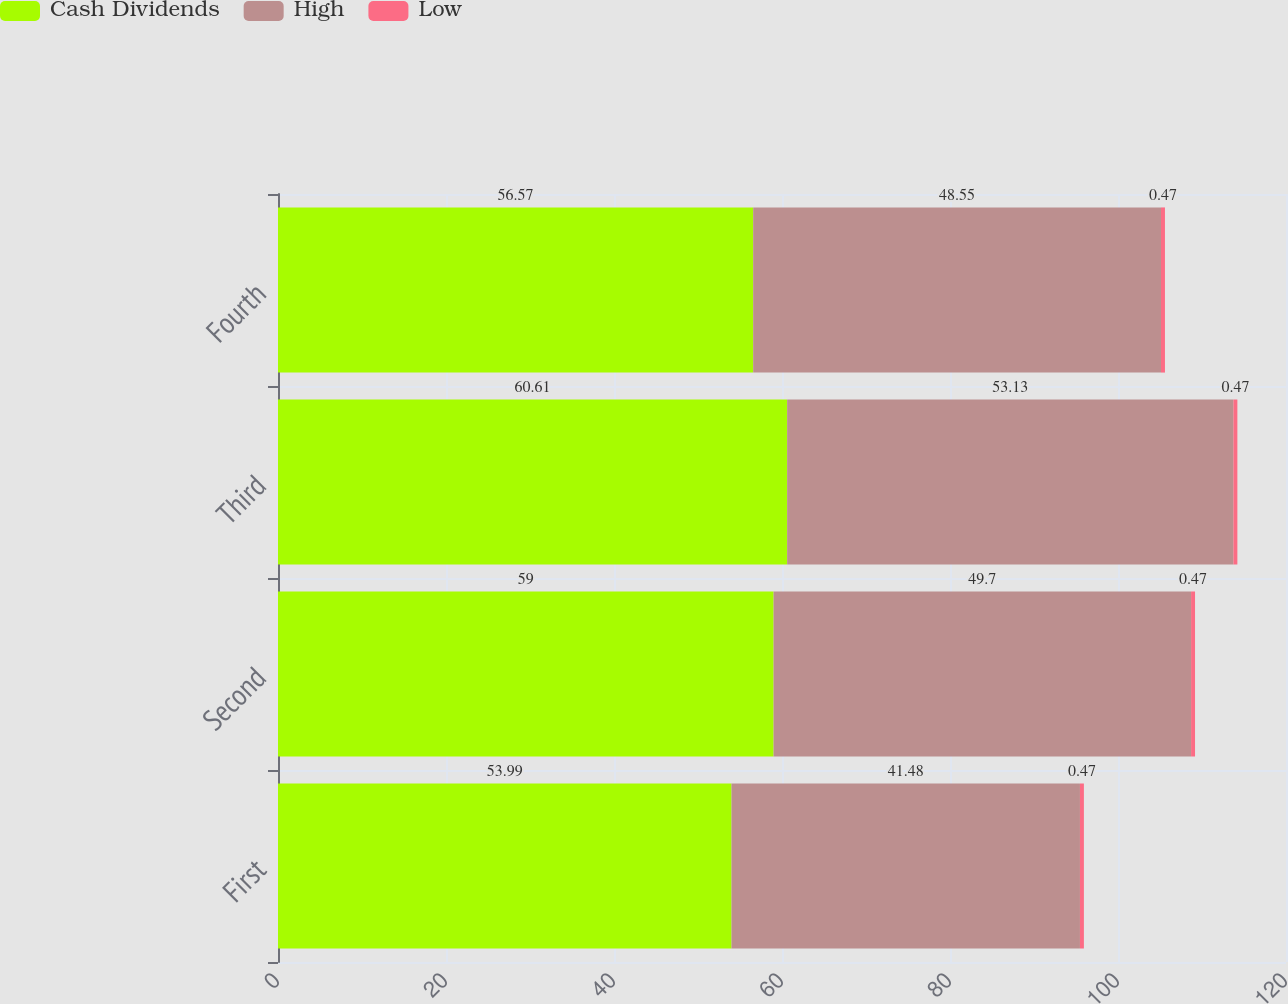<chart> <loc_0><loc_0><loc_500><loc_500><stacked_bar_chart><ecel><fcel>First<fcel>Second<fcel>Third<fcel>Fourth<nl><fcel>Cash Dividends<fcel>53.99<fcel>59<fcel>60.61<fcel>56.57<nl><fcel>High<fcel>41.48<fcel>49.7<fcel>53.13<fcel>48.55<nl><fcel>Low<fcel>0.47<fcel>0.47<fcel>0.47<fcel>0.47<nl></chart> 